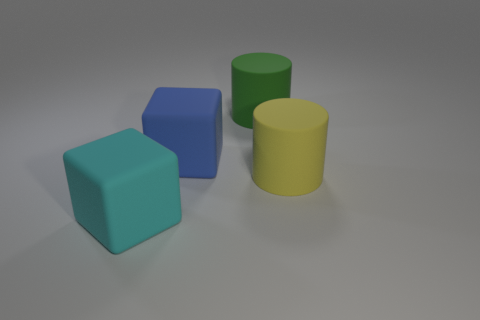Does the cube in front of the big yellow cylinder have the same material as the big block behind the big cyan rubber thing?
Give a very brief answer. Yes. Is the number of big green metal things greater than the number of large blue matte things?
Offer a very short reply. No. Does the big yellow thing have the same material as the large cyan block?
Keep it short and to the point. Yes. Are there fewer small gray shiny things than large yellow objects?
Give a very brief answer. Yes. Does the big cyan thing have the same shape as the green thing?
Give a very brief answer. No. How many other things are made of the same material as the cyan thing?
Your answer should be very brief. 3. How many brown objects are either big cylinders or matte blocks?
Keep it short and to the point. 0. There is a object that is right of the large green rubber object; is its shape the same as the matte thing that is in front of the large yellow cylinder?
Your answer should be very brief. No. How many things are rubber objects or large blocks to the right of the big cyan cube?
Provide a succinct answer. 4. What is the material of the large thing that is both left of the yellow thing and right of the blue rubber cube?
Give a very brief answer. Rubber. 